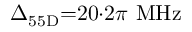Convert formula to latex. <formula><loc_0><loc_0><loc_500><loc_500>\Delta _ { 5 5 D } { = } 2 0 { \cdot } 2 \pi \ M H z</formula> 